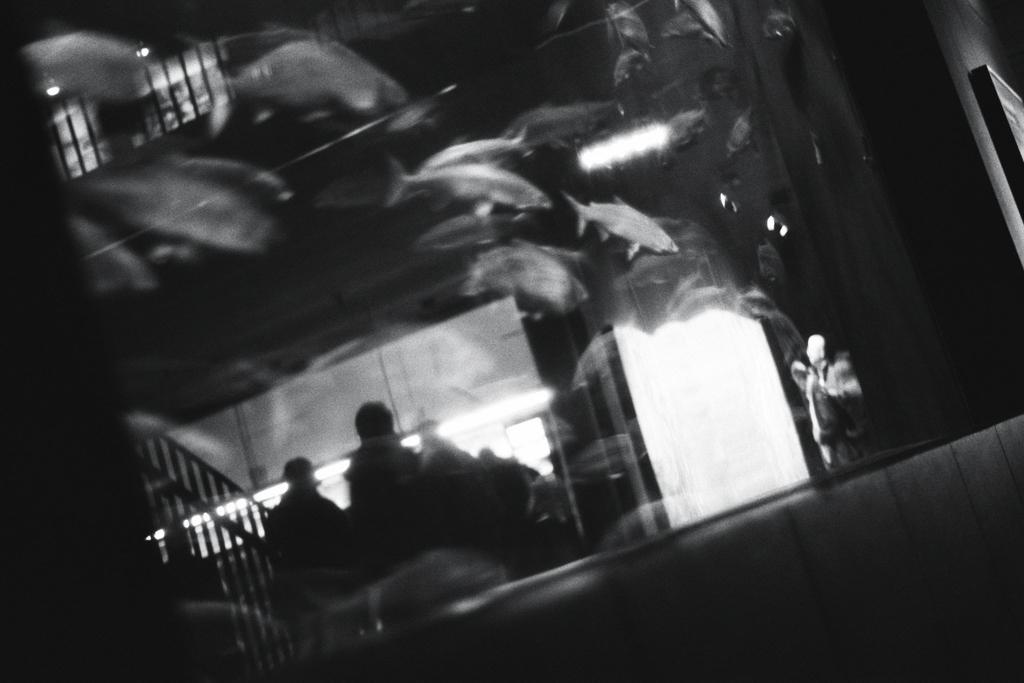Where was the image most likely taken? The image was likely taken indoors. What can be seen in the foreground of the image? There are fishes swimming in an aquarium in the foreground. Can you identify any people in the image? Yes, there is a person visible in the image. What feature is present that might be used for support or safety? A handrail is present in the image. What other objects can be seen in the image besides the aquarium and handrail? There are other unspecified objects in the image. What type of celery is being used as a decoration in the image? There is no celery present in the image. Can you describe the linen used to cover the aquarium in the image? There is no linen covering the aquarium in the image; it is made of glass and visible in the foreground. 